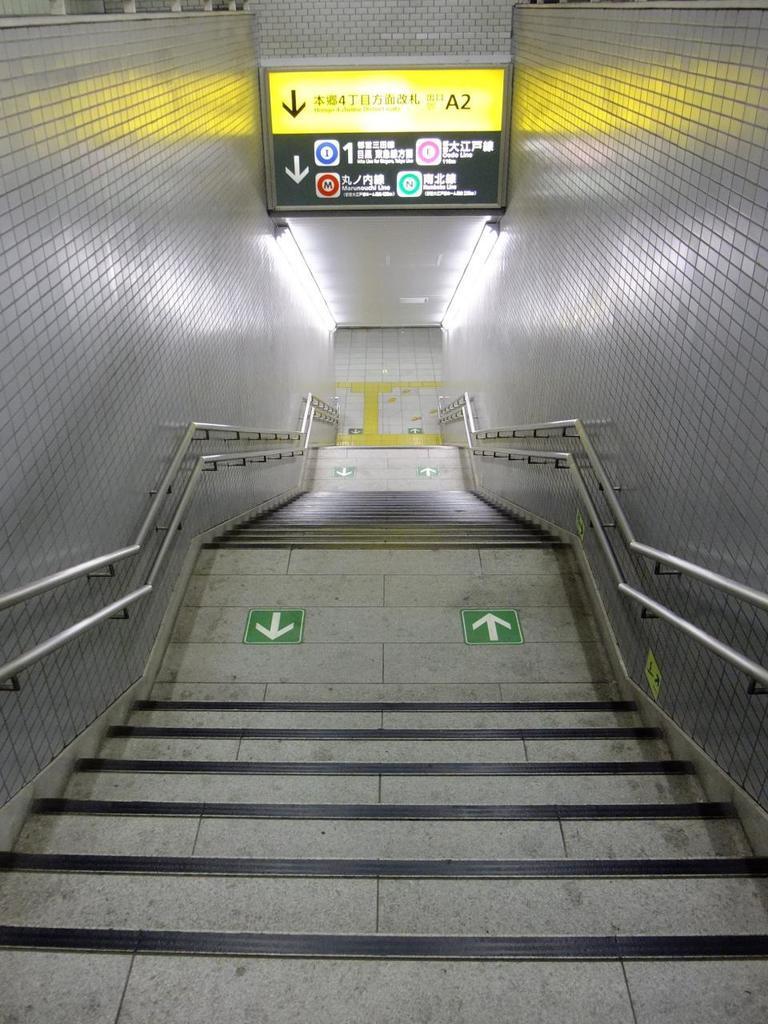Please provide a concise description of this image. In the foreground of this picture we can see the stairs and we can see the arrows on the stair and we can see the handrails on both the sides. At the top we can see a screen on which we can see the text, numbers and some other objects and we can see the wall. 